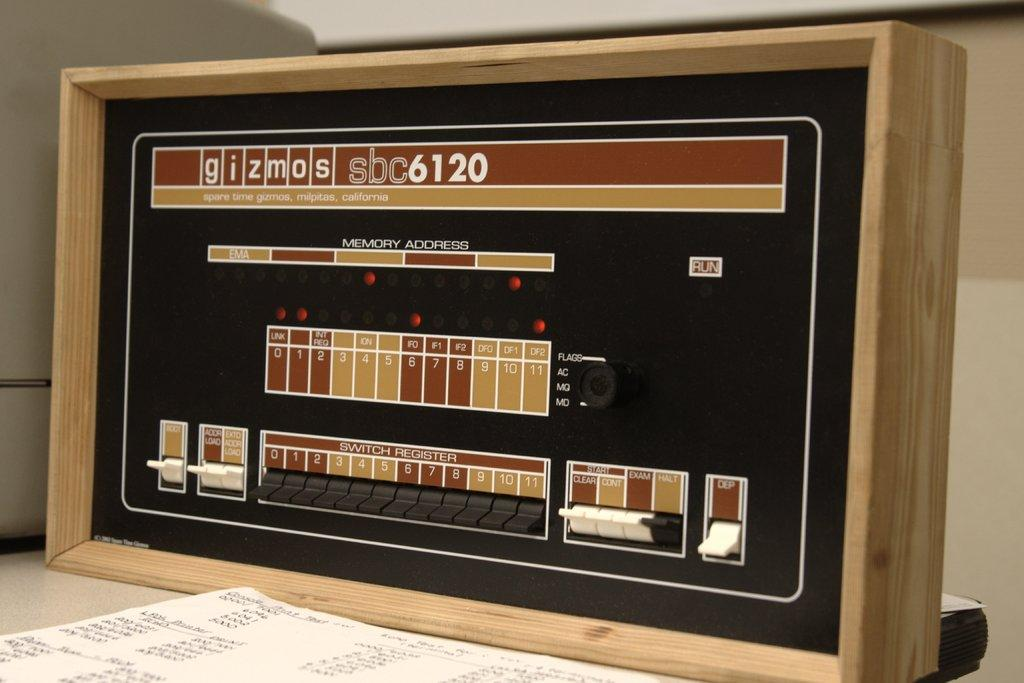<image>
Offer a succinct explanation of the picture presented. A panel with switches ad numbers by Gizmos has a retro look to it. 